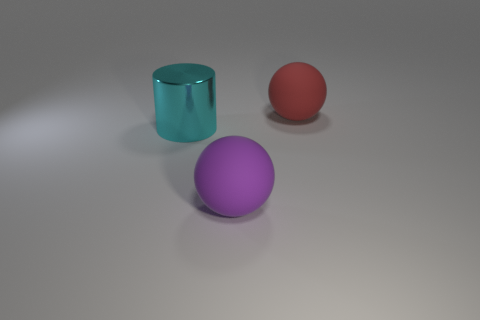Add 1 purple spheres. How many objects exist? 4 Subtract all cylinders. How many objects are left? 2 Subtract all purple balls. How many balls are left? 1 Subtract 1 balls. How many balls are left? 1 Add 2 red objects. How many red objects are left? 3 Add 3 small purple blocks. How many small purple blocks exist? 3 Subtract 0 yellow blocks. How many objects are left? 3 Subtract all green cylinders. Subtract all green spheres. How many cylinders are left? 1 Subtract all cyan objects. Subtract all large red matte objects. How many objects are left? 1 